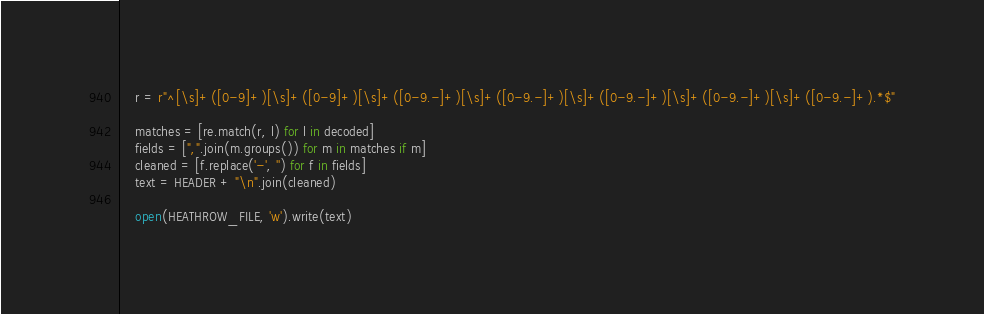<code> <loc_0><loc_0><loc_500><loc_500><_Python_>    r = r"^[\s]+([0-9]+)[\s]+([0-9]+)[\s]+([0-9.-]+)[\s]+([0-9.-]+)[\s]+([0-9.-]+)[\s]+([0-9.-]+)[\s]+([0-9.-]+).*$"

    matches = [re.match(r, l) for l in decoded]
    fields = [",".join(m.groups()) for m in matches if m]
    cleaned = [f.replace('-', '') for f in fields]
    text = HEADER + "\n".join(cleaned)

    open(HEATHROW_FILE, 'w').write(text)
</code> 